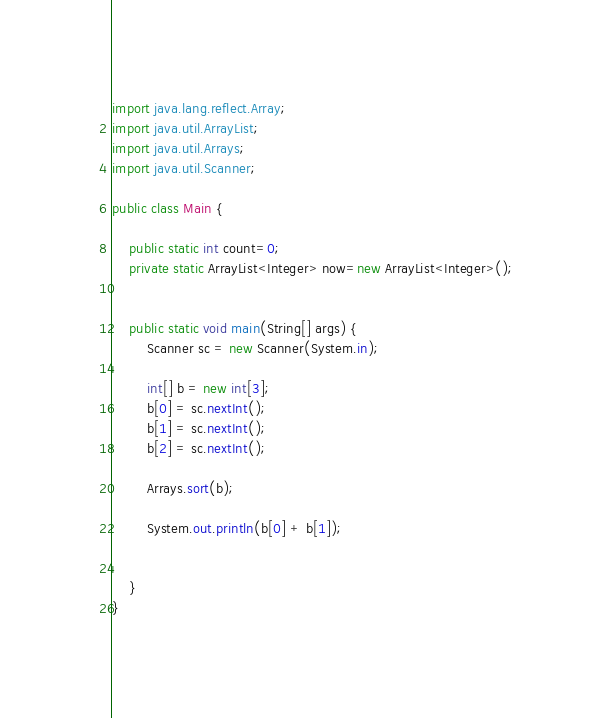<code> <loc_0><loc_0><loc_500><loc_500><_Java_>import java.lang.reflect.Array;
import java.util.ArrayList;
import java.util.Arrays;
import java.util.Scanner;

public class Main {

    public static int count=0;
    private static ArrayList<Integer> now=new ArrayList<Integer>();


    public static void main(String[] args) {
        Scanner sc = new Scanner(System.in);

        int[] b = new int[3];
        b[0] = sc.nextInt();
        b[1] = sc.nextInt();
        b[2] = sc.nextInt();

        Arrays.sort(b);

        System.out.println(b[0] + b[1]);


    }
}</code> 